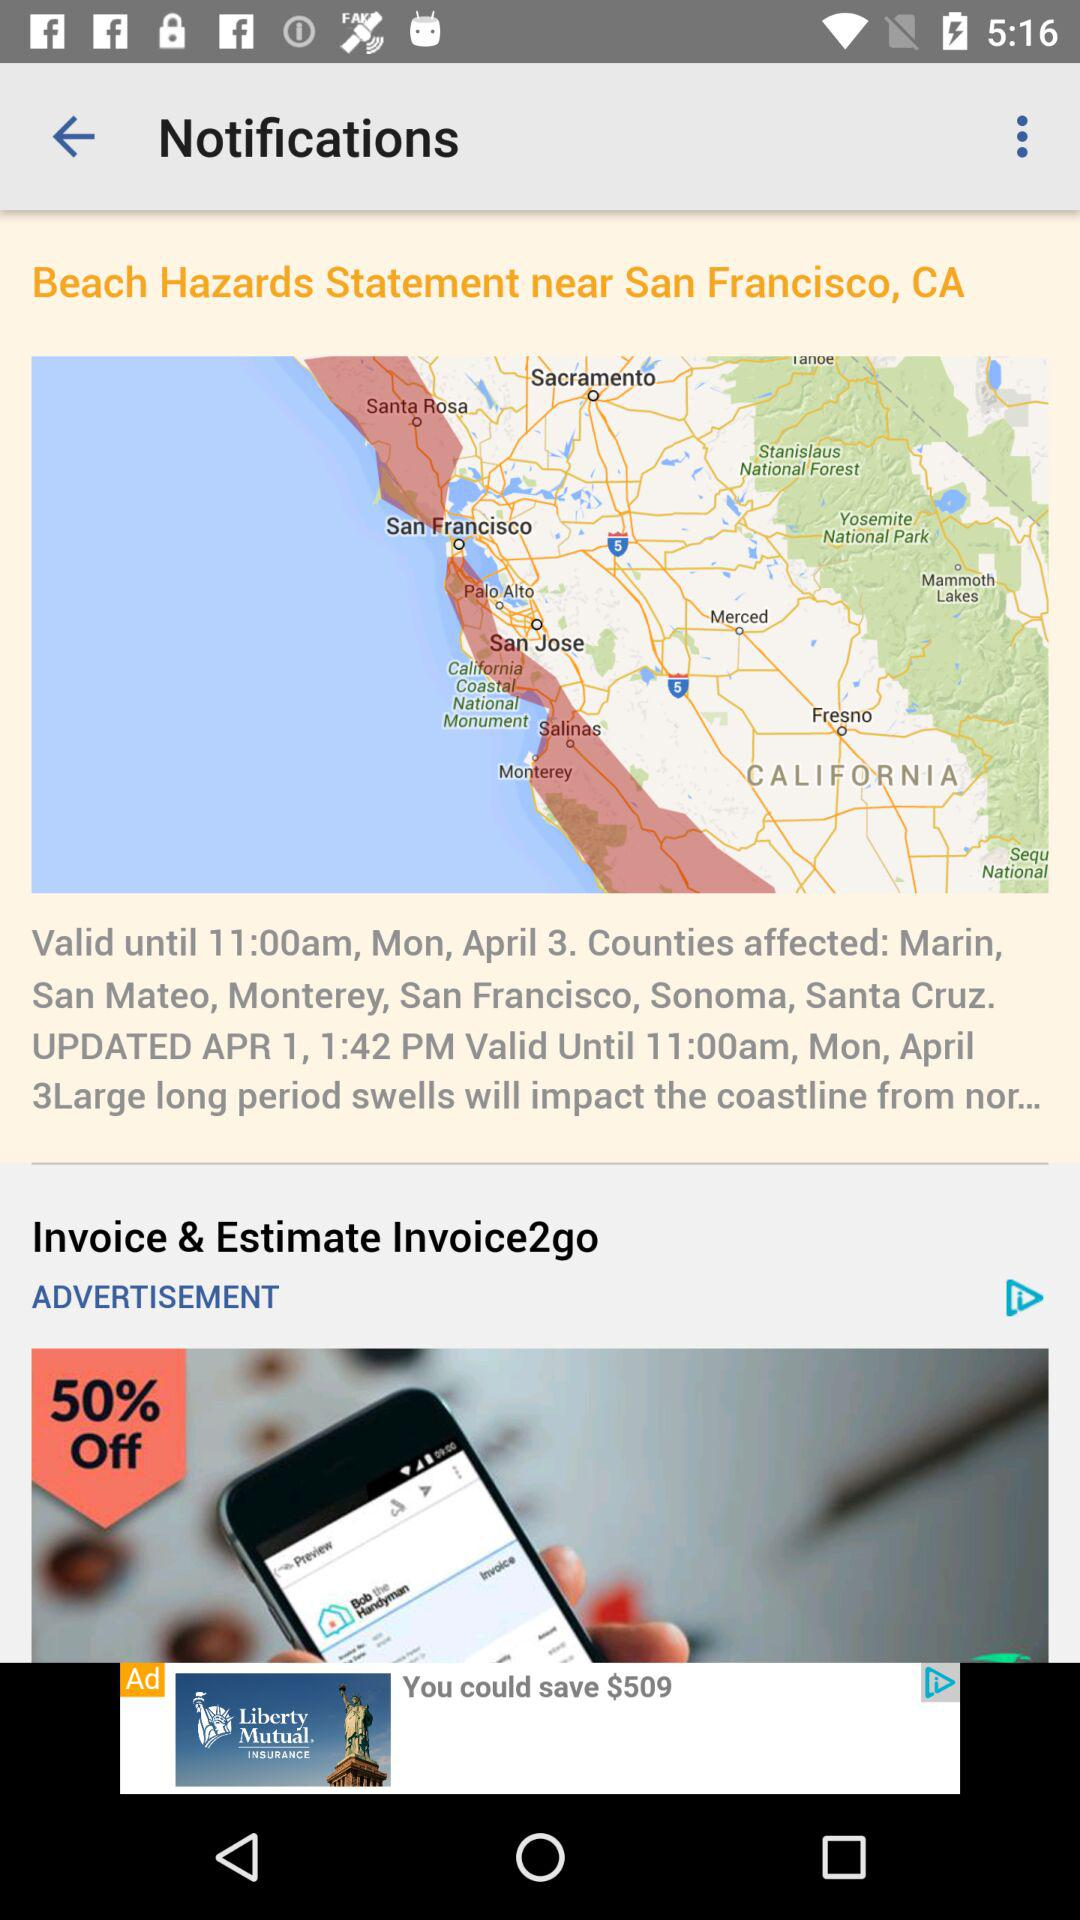What is the current location? The current location is San Francisco, CA. 